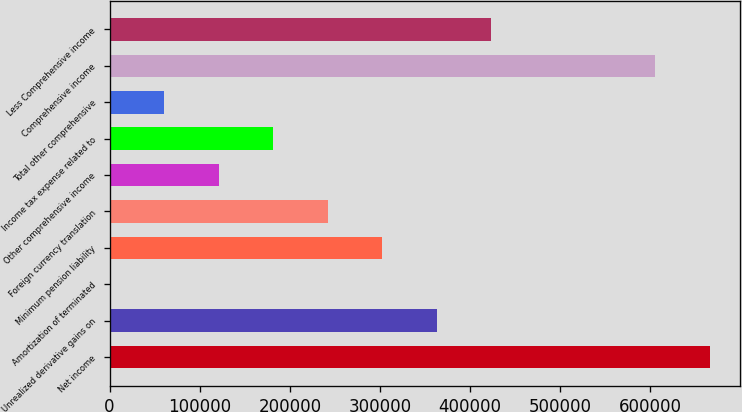<chart> <loc_0><loc_0><loc_500><loc_500><bar_chart><fcel>Net income<fcel>Unrealized derivative gains on<fcel>Amortization of terminated<fcel>Minimum pension liability<fcel>Foreign currency translation<fcel>Other comprehensive income<fcel>Income tax expense related to<fcel>Total other comprehensive<fcel>Comprehensive income<fcel>Less Comprehensive income<nl><fcel>665853<fcel>363132<fcel>336<fcel>302666<fcel>242200<fcel>121268<fcel>181734<fcel>60802<fcel>605387<fcel>423598<nl></chart> 